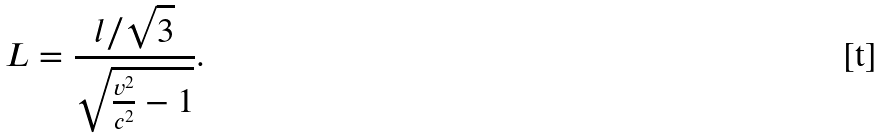<formula> <loc_0><loc_0><loc_500><loc_500>L = \frac { l / \sqrt { 3 } } { \sqrt { \frac { v ^ { 2 } } { c ^ { 2 } } - 1 } } .</formula> 